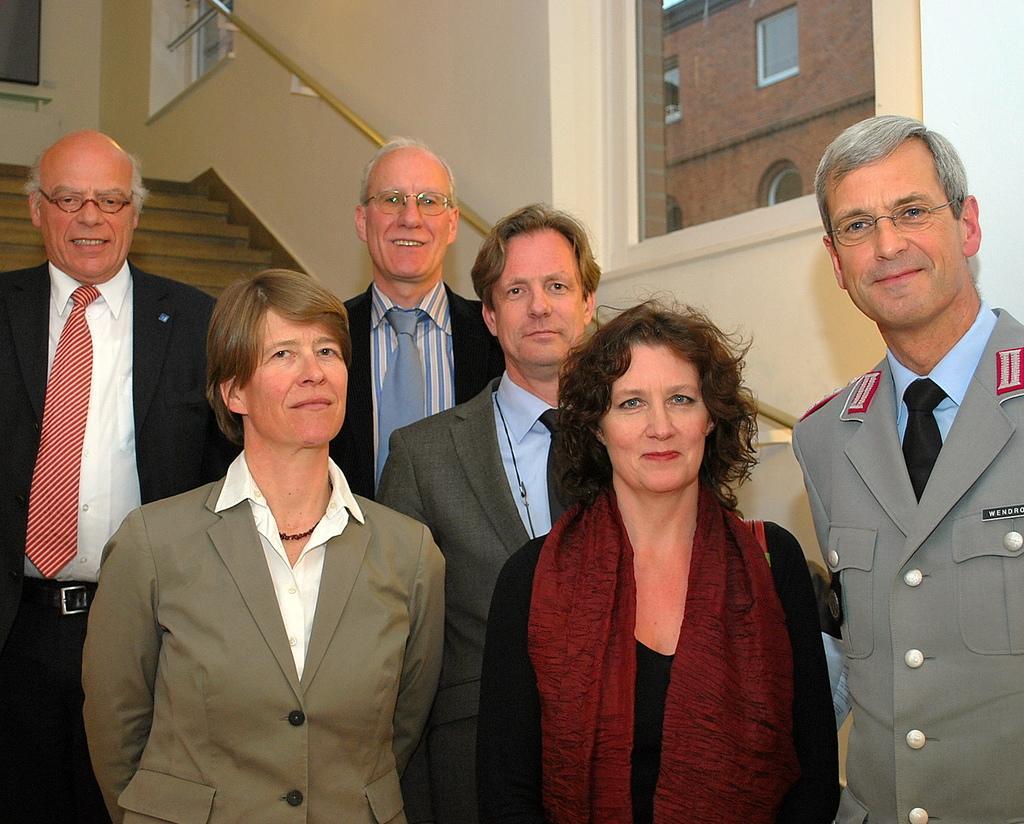Can you describe this image briefly? There are people standing. In the background we can see steps,rod,wall and glass windows,through this window we can see wall and windows. 